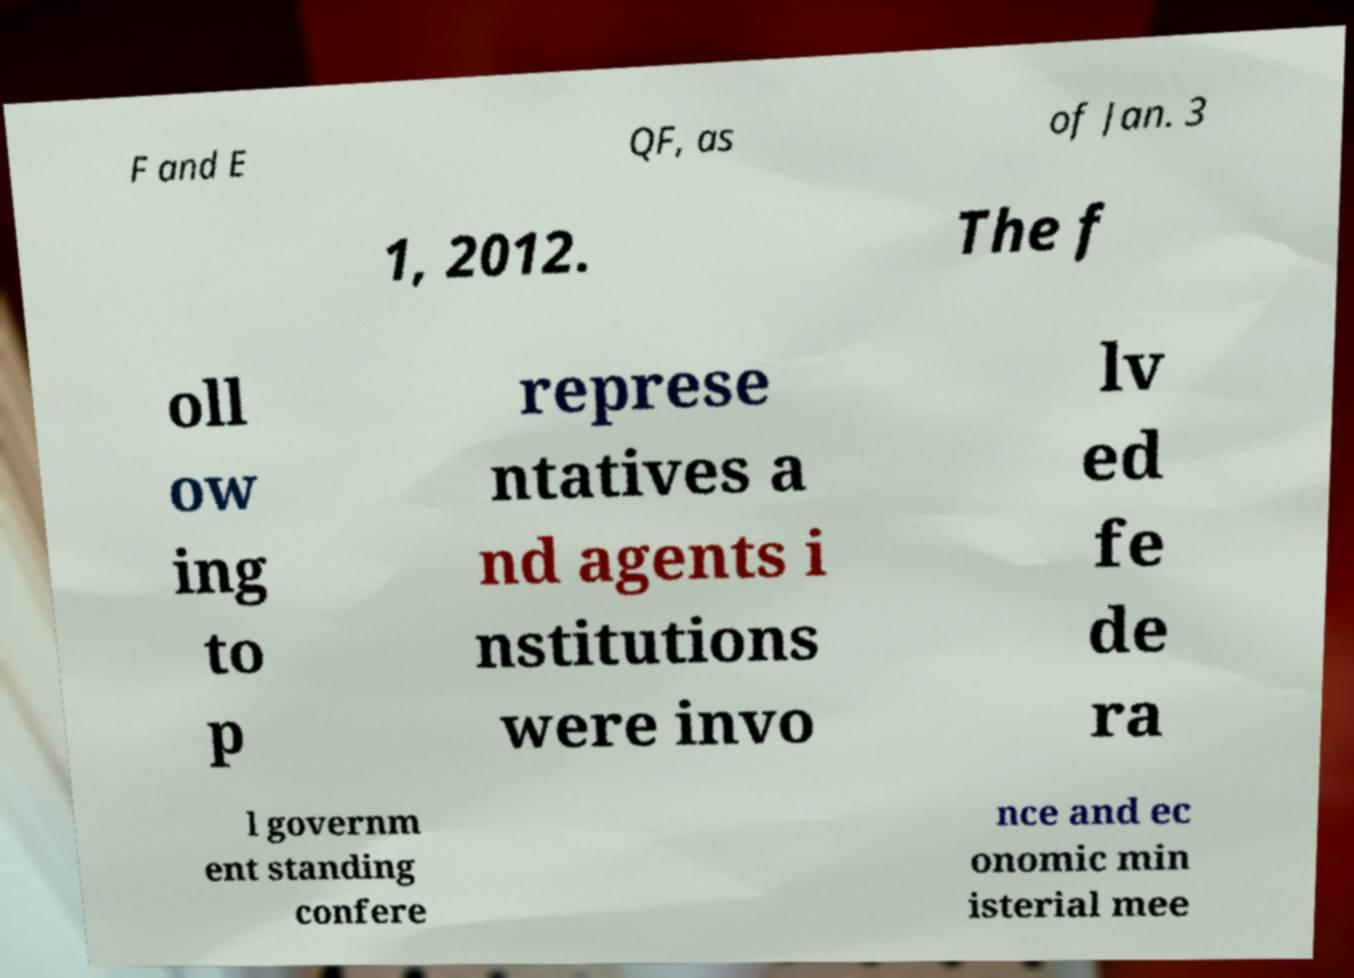Can you accurately transcribe the text from the provided image for me? F and E QF, as of Jan. 3 1, 2012. The f oll ow ing to p represe ntatives a nd agents i nstitutions were invo lv ed fe de ra l governm ent standing confere nce and ec onomic min isterial mee 